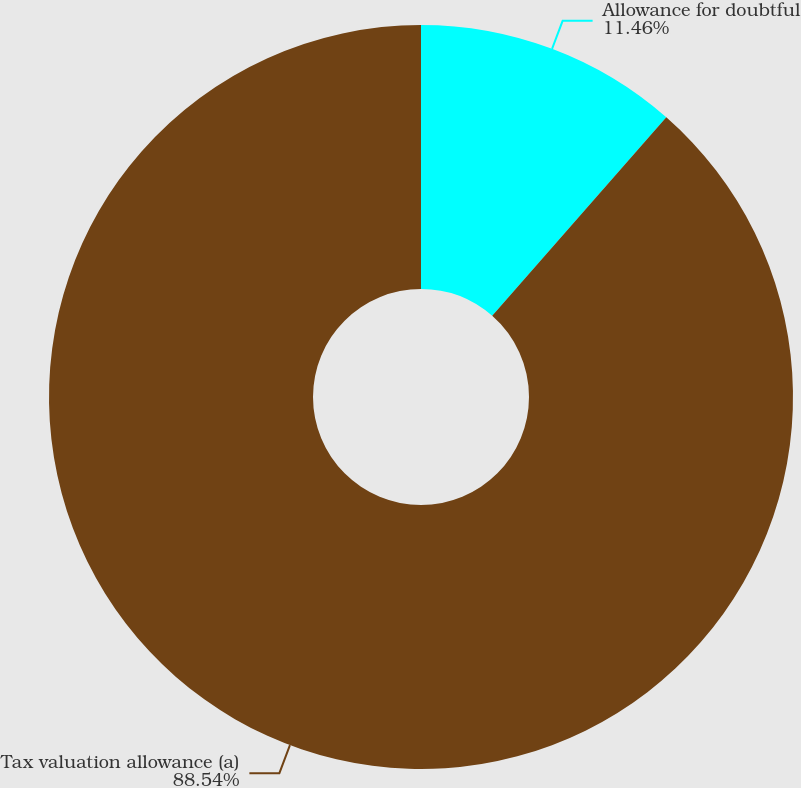<chart> <loc_0><loc_0><loc_500><loc_500><pie_chart><fcel>Allowance for doubtful<fcel>Tax valuation allowance (a)<nl><fcel>11.46%<fcel>88.54%<nl></chart> 